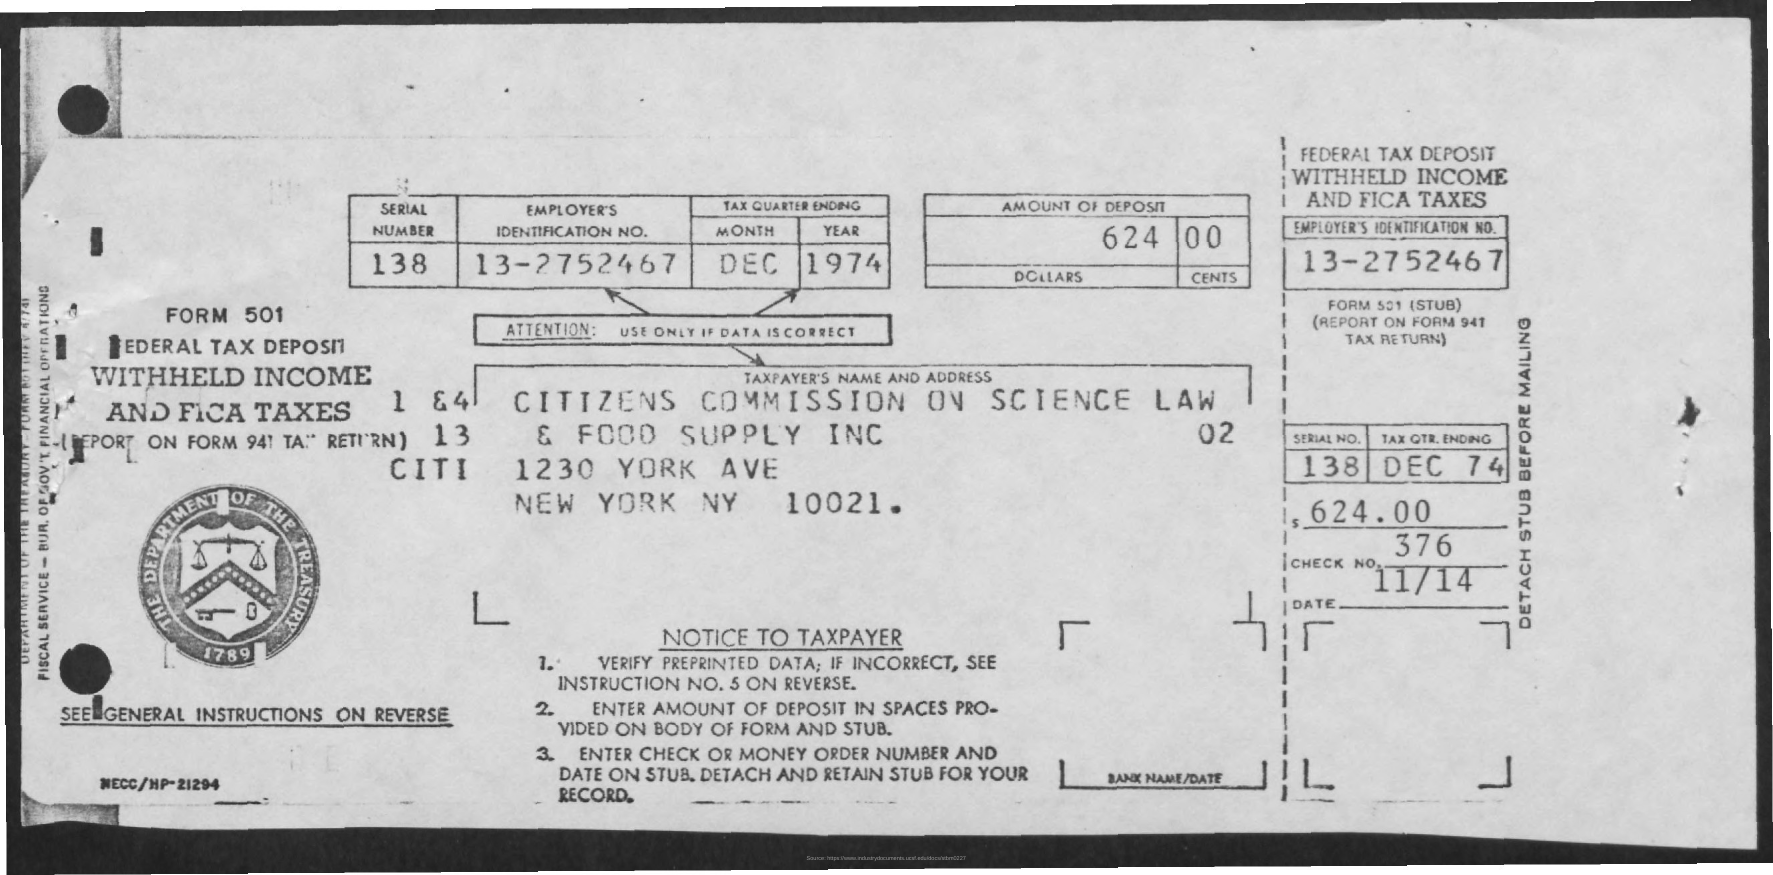What is the Year?
 1974 